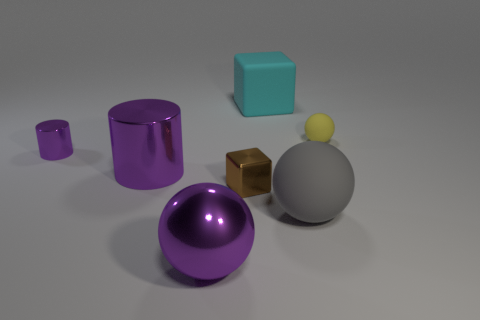Is the metal ball the same color as the small metallic cylinder?
Give a very brief answer. Yes. There is a block that is to the right of the brown block; does it have the same size as the large metal ball?
Make the answer very short. Yes. What number of matte things are either large gray balls or small gray spheres?
Your answer should be compact. 1. What number of things are to the left of the matte ball behind the large gray rubber ball?
Offer a terse response. 6. What shape is the matte object that is behind the gray matte sphere and on the left side of the tiny rubber sphere?
Give a very brief answer. Cube. There is a large ball that is on the right side of the large shiny thing that is in front of the big matte object that is to the right of the large cyan rubber cube; what is it made of?
Your answer should be compact. Rubber. The other cylinder that is the same color as the big cylinder is what size?
Provide a succinct answer. Small. What is the brown cube made of?
Ensure brevity in your answer.  Metal. Are the brown thing and the gray ball left of the yellow matte ball made of the same material?
Your response must be concise. No. There is a large sphere that is in front of the large rubber object that is right of the cyan rubber cube; what is its color?
Ensure brevity in your answer.  Purple. 